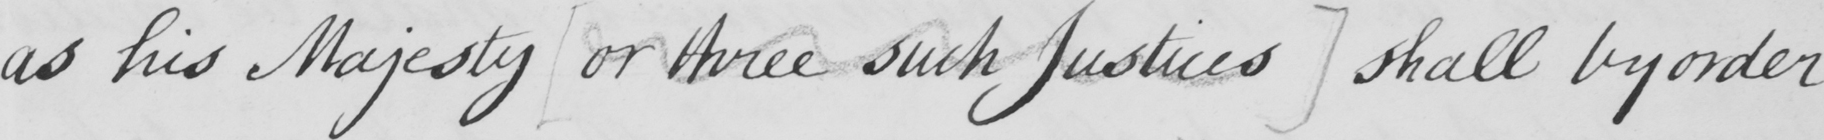Transcribe the text shown in this historical manuscript line. as his Majesty  [ or three such Justices ]  shall by order 